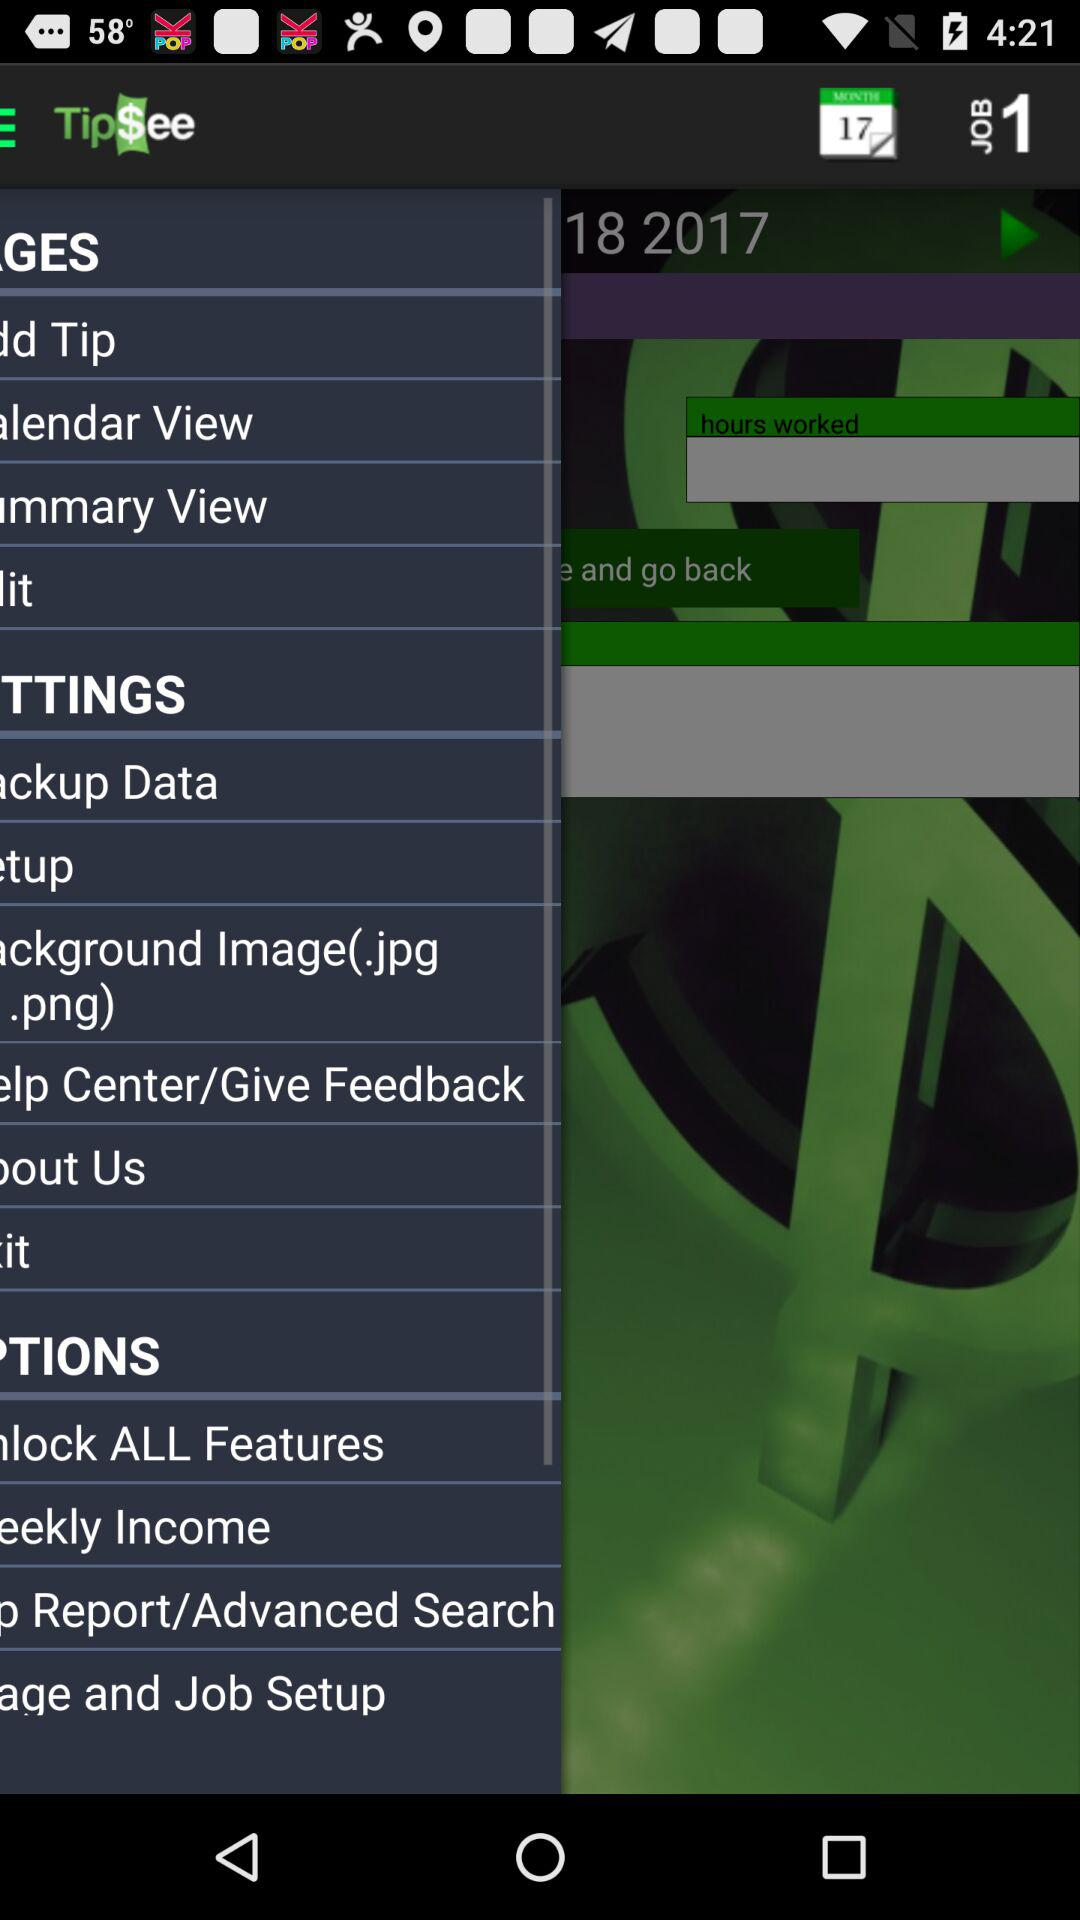Which month's data is shown? The data is shown for February. 